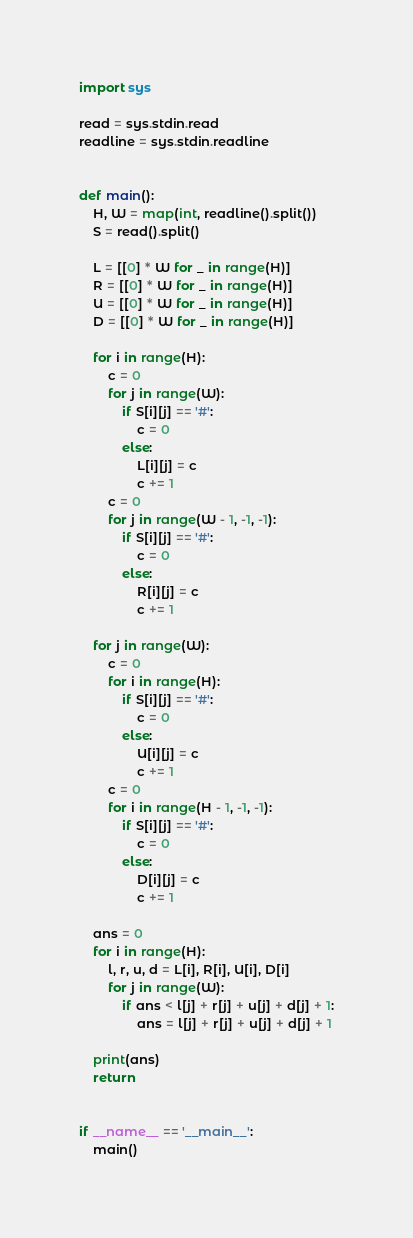Convert code to text. <code><loc_0><loc_0><loc_500><loc_500><_Python_>import sys

read = sys.stdin.read
readline = sys.stdin.readline


def main():
    H, W = map(int, readline().split())
    S = read().split()

    L = [[0] * W for _ in range(H)]
    R = [[0] * W for _ in range(H)]
    U = [[0] * W for _ in range(H)]
    D = [[0] * W for _ in range(H)]

    for i in range(H):
        c = 0
        for j in range(W):
            if S[i][j] == '#':
                c = 0
            else:
                L[i][j] = c
                c += 1
        c = 0
        for j in range(W - 1, -1, -1):
            if S[i][j] == '#':
                c = 0
            else:
                R[i][j] = c
                c += 1

    for j in range(W):
        c = 0
        for i in range(H):
            if S[i][j] == '#':
                c = 0
            else:
                U[i][j] = c
                c += 1
        c = 0
        for i in range(H - 1, -1, -1):
            if S[i][j] == '#':
                c = 0
            else:
                D[i][j] = c
                c += 1

    ans = 0
    for i in range(H):
        l, r, u, d = L[i], R[i], U[i], D[i]
        for j in range(W):
            if ans < l[j] + r[j] + u[j] + d[j] + 1:
                ans = l[j] + r[j] + u[j] + d[j] + 1

    print(ans)
    return


if __name__ == '__main__':
    main()
</code> 